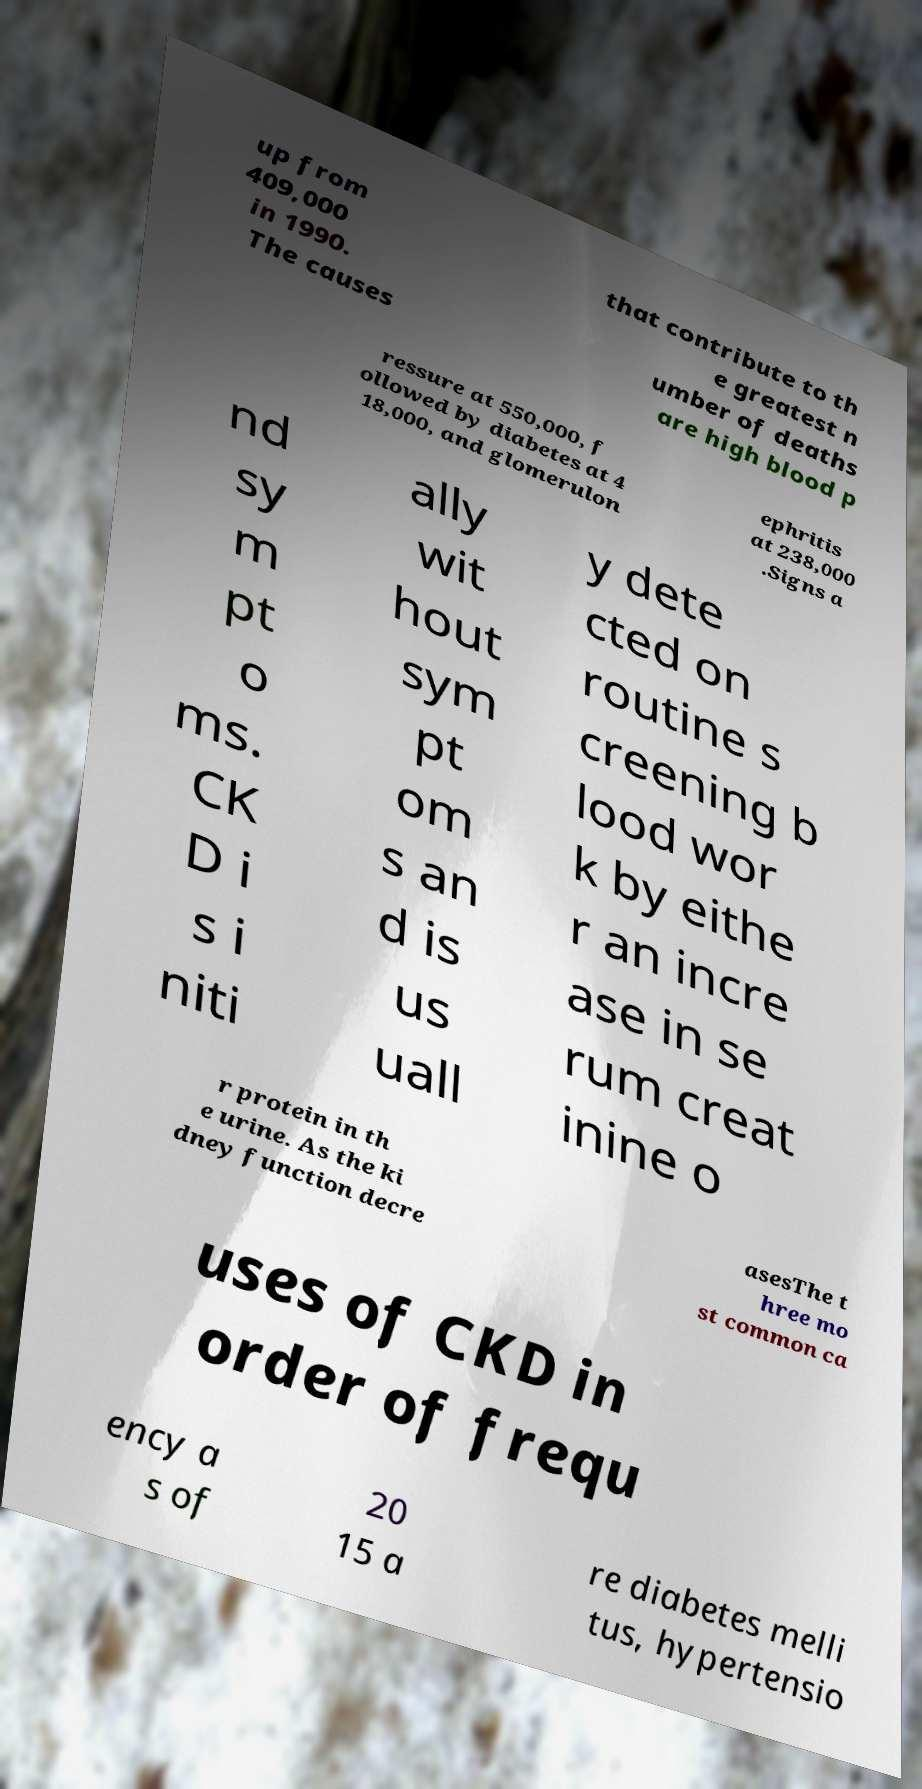Please identify and transcribe the text found in this image. up from 409,000 in 1990. The causes that contribute to th e greatest n umber of deaths are high blood p ressure at 550,000, f ollowed by diabetes at 4 18,000, and glomerulon ephritis at 238,000 .Signs a nd sy m pt o ms. CK D i s i niti ally wit hout sym pt om s an d is us uall y dete cted on routine s creening b lood wor k by eithe r an incre ase in se rum creat inine o r protein in th e urine. As the ki dney function decre asesThe t hree mo st common ca uses of CKD in order of frequ ency a s of 20 15 a re diabetes melli tus, hypertensio 